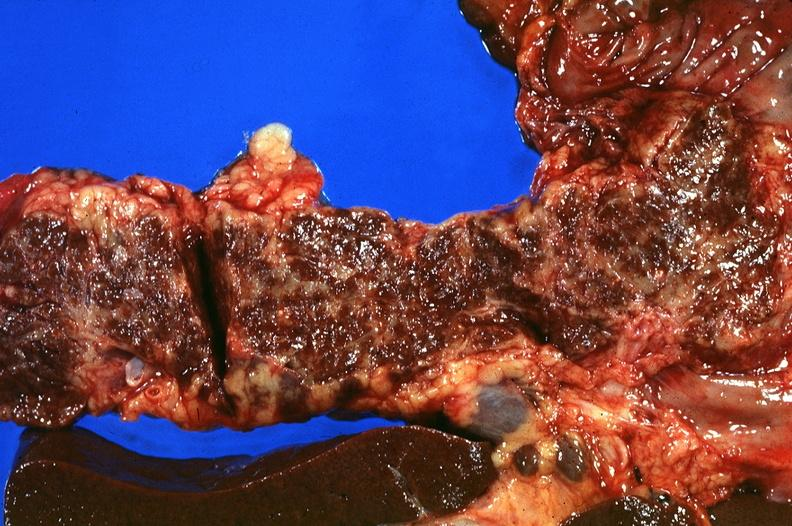does embryo-fetus show pancreas, hemochromatosis?
Answer the question using a single word or phrase. No 